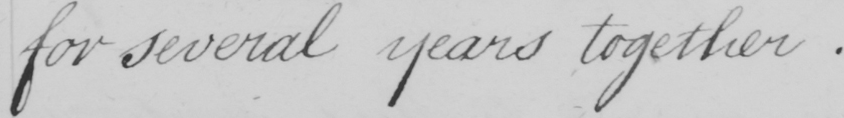Transcribe the text shown in this historical manuscript line. for several years together . 